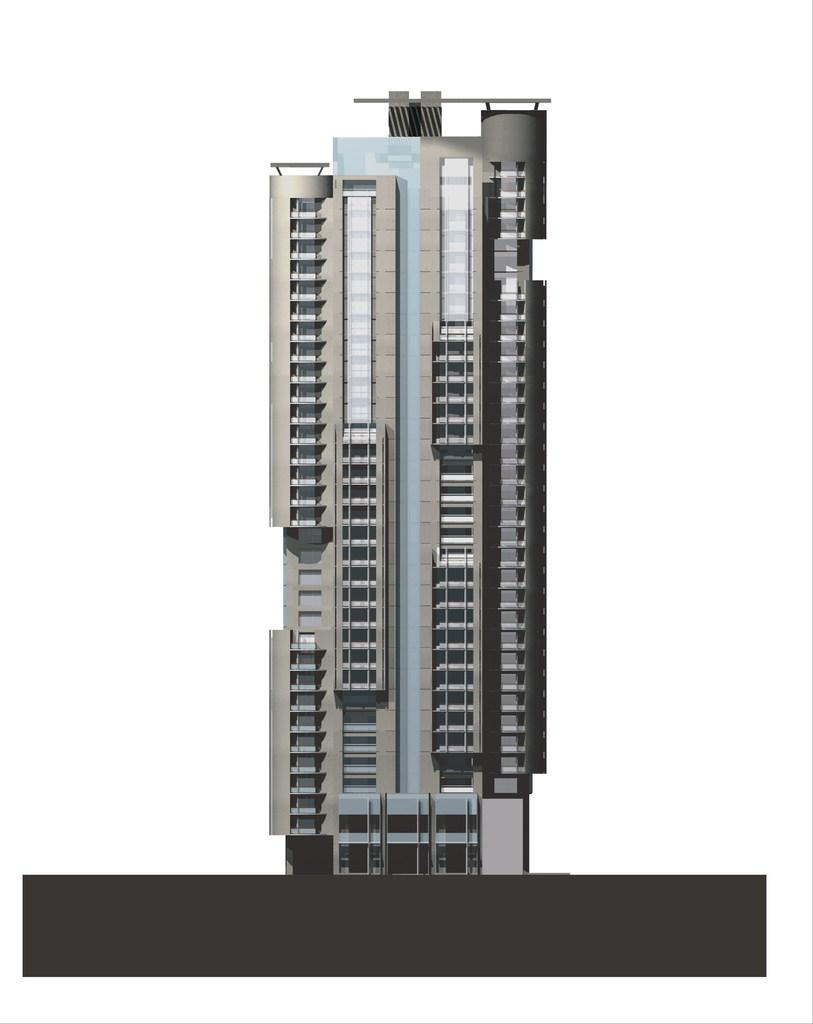What type of structure is the main subject of the image? There is a tower building in the image. What color is the background of the image? The background of the image is white. What type of writing can be seen on the roof of the tower building in the image? There is no writing visible on the roof of the tower building in the image, as the roof is not shown in the image. 